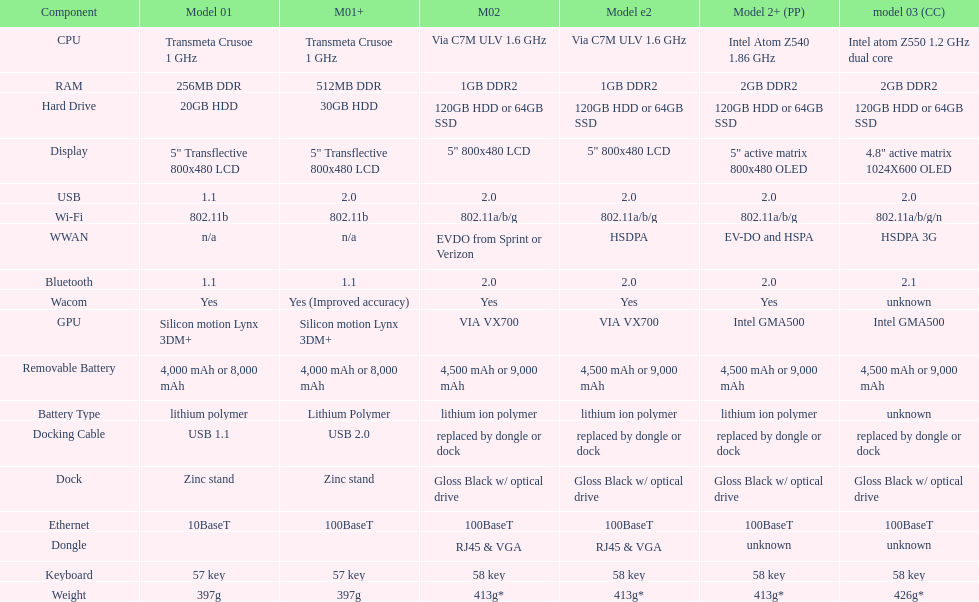Are there at least 13 different components on the chart? Yes. 